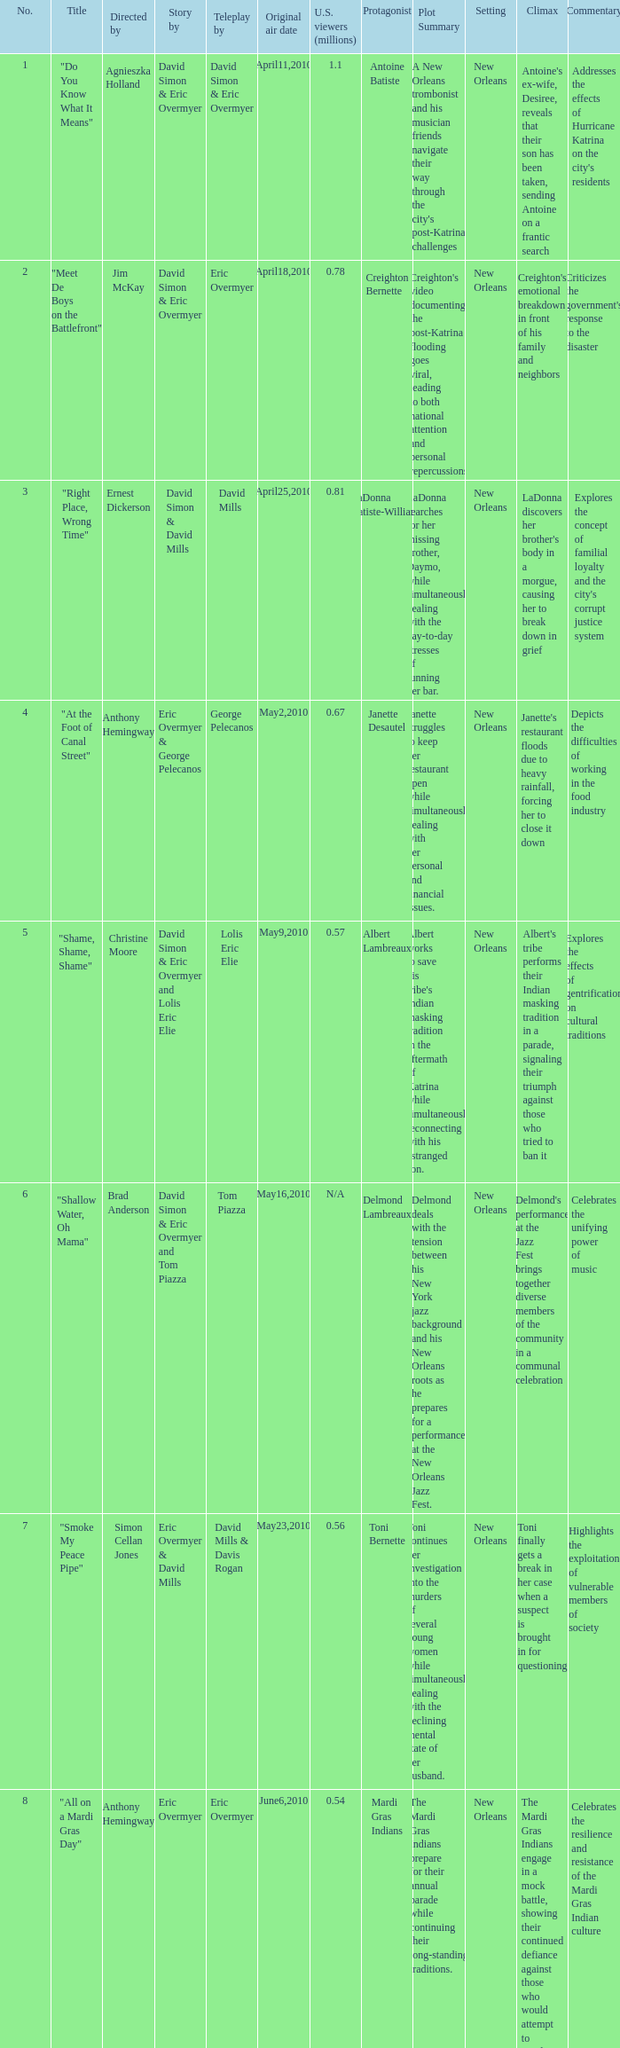Name the most number 9.0. 